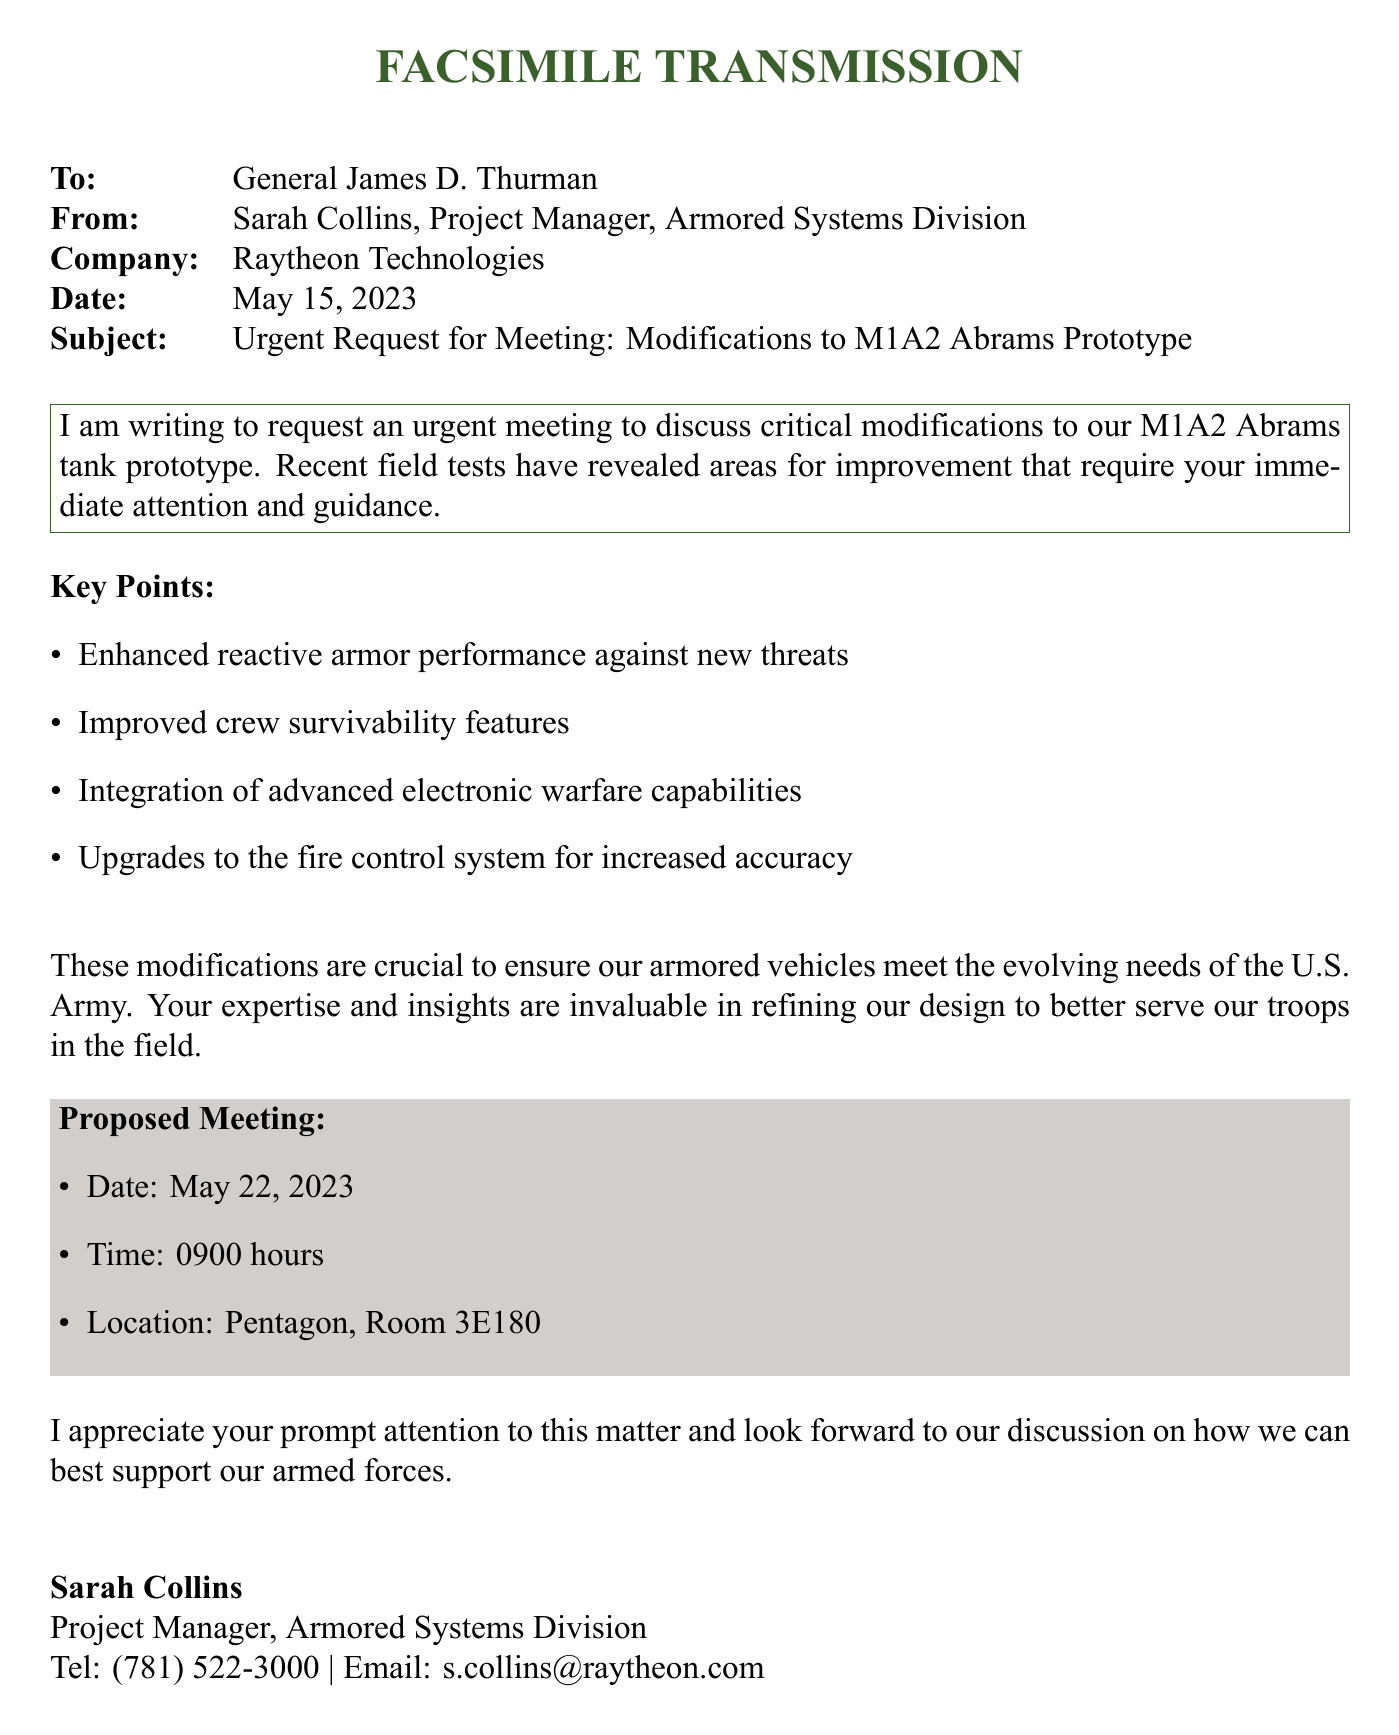what is the date of the meeting? The date of the proposed meeting is explicitly stated in the document as May 22, 2023.
Answer: May 22, 2023 who is the sender of the fax? The sender is identified in the document as Sarah Collins, Project Manager of the Armored Systems Division.
Answer: Sarah Collins what is the subject of the fax? The subject line of the fax provides specific information about the content, which is an urgent request for a meeting regarding modifications to a prototype.
Answer: Urgent Request for Meeting: Modifications to M1A2 Abrams Prototype which tank prototype is being discussed? The document clearly mentions the M1A2 Abrams tank prototype as the focus for the requested modifications.
Answer: M1A2 Abrams what time is the proposed meeting? The proposed time for the meeting is mentioned in the details provided in the document.
Answer: 0900 hours why are modifications to the armored vehicle needed? The document states that recent field tests have revealed areas for improvement, thus requiring modifications to enhance vehicle performance and crew safety.
Answer: Areas for improvement what aspect of the armored vehicle does the document specifically highlight? The document lists enhanced reactive armor performance, crew survivability, electronic warfare, and fire control system as key aspects being addressed.
Answer: Enhanced reactive armor performance what is the recipient's title? The recipient's title is explicitly provided in the document.
Answer: General where is the meeting location? The document specifies the location of the meeting to be at the Pentagon, Room 3E180.
Answer: Pentagon, Room 3E180 